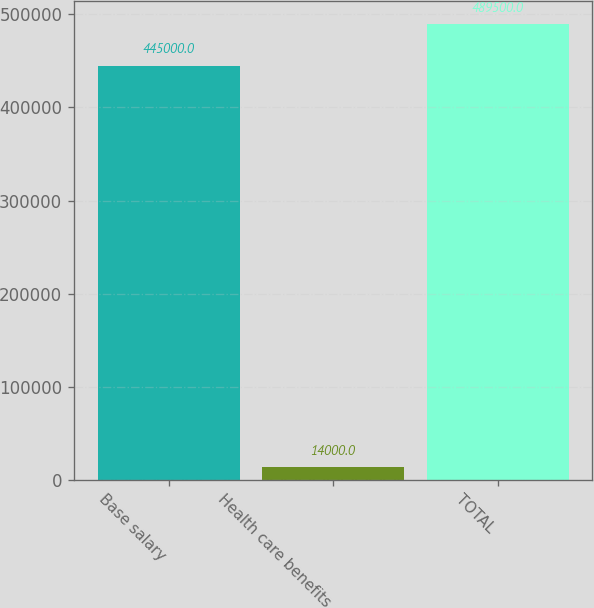<chart> <loc_0><loc_0><loc_500><loc_500><bar_chart><fcel>Base salary<fcel>Health care benefits<fcel>TOTAL<nl><fcel>445000<fcel>14000<fcel>489500<nl></chart> 